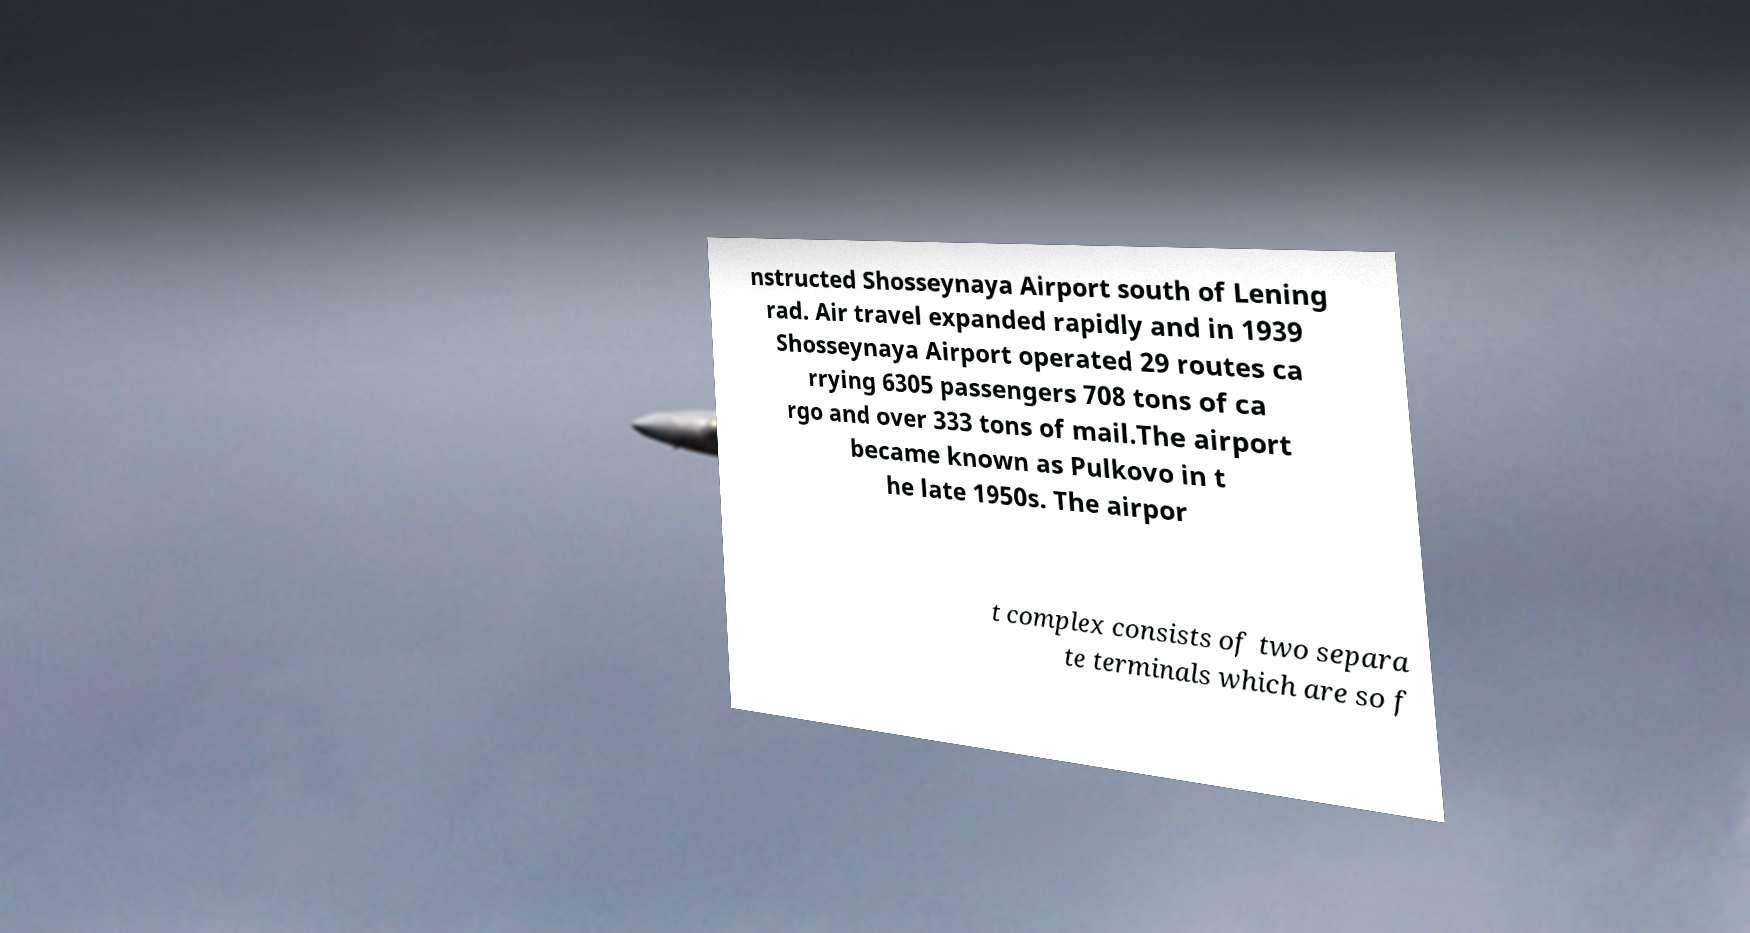Could you assist in decoding the text presented in this image and type it out clearly? nstructed Shosseynaya Airport south of Lening rad. Air travel expanded rapidly and in 1939 Shosseynaya Airport operated 29 routes ca rrying 6305 passengers 708 tons of ca rgo and over 333 tons of mail.The airport became known as Pulkovo in t he late 1950s. The airpor t complex consists of two separa te terminals which are so f 